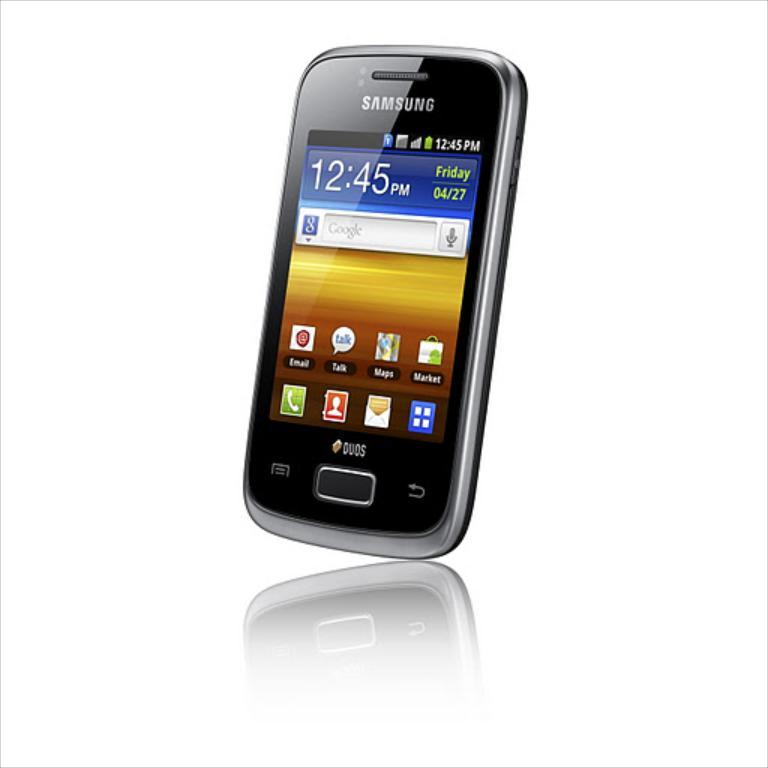Provide a one-sentence caption for the provided image. the screen of a samsung branded cell phone whose time reads 12:45. 